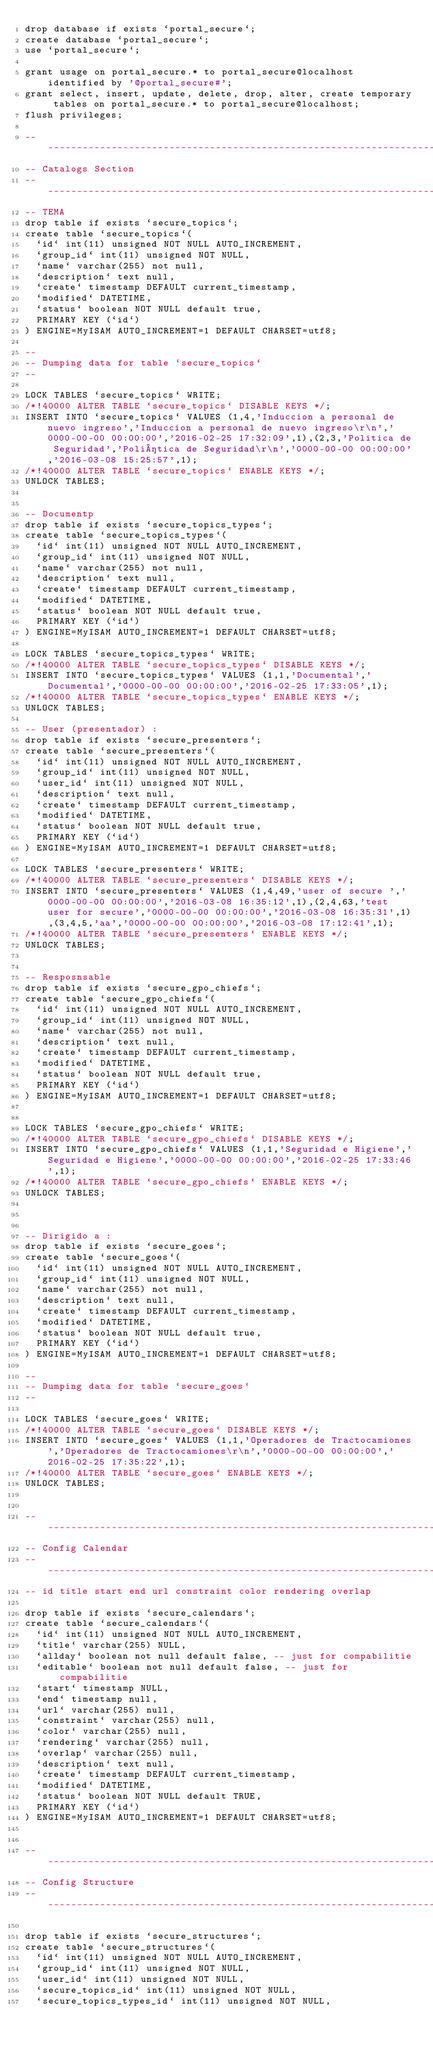<code> <loc_0><loc_0><loc_500><loc_500><_SQL_>drop database if exists `portal_secure`; 
create database `portal_secure`;
use `portal_secure`;

grant usage on portal_secure.* to portal_secure@localhost identified by '@portal_secure#';
grant select, insert, update, delete, drop, alter, create temporary tables on portal_secure.* to portal_secure@localhost;
flush privileges;

-- ---------------------------------------------------------------------------------------------------------------------------------------------------
-- Catalogs Section
-- ---------------------------------------------------------------------------------------------------------------------------------------------------
-- TEMA
drop table if exists `secure_topics`;
create table `secure_topics`(
  `id` int(11) unsigned NOT NULL AUTO_INCREMENT,
  `group_id` int(11) unsigned NOT NULL,
  `name` varchar(255) not null,
  `description` text null,
  `create` timestamp DEFAULT current_timestamp,
  `modified` DATETIME,
  `status` boolean NOT NULL default true,
  PRIMARY KEY (`id`)
) ENGINE=MyISAM AUTO_INCREMENT=1 DEFAULT CHARSET=utf8;

--
-- Dumping data for table `secure_topics`
--

LOCK TABLES `secure_topics` WRITE;
/*!40000 ALTER TABLE `secure_topics` DISABLE KEYS */;
INSERT INTO `secure_topics` VALUES (1,4,'Induccion a personal de nuevo ingreso','Induccion a personal de nuevo ingreso\r\n','0000-00-00 00:00:00','2016-02-25 17:32:09',1),(2,3,'Politica de Seguridad','Poli­tica de Seguridad\r\n','0000-00-00 00:00:00','2016-03-08 15:25:57',1);
/*!40000 ALTER TABLE `secure_topics` ENABLE KEYS */;
UNLOCK TABLES;


-- Documentp
drop table if exists `secure_topics_types`;
create table `secure_topics_types`(
  `id` int(11) unsigned NOT NULL AUTO_INCREMENT,
  `group_id` int(11) unsigned NOT NULL,
  `name` varchar(255) not null,
  `description` text null,
  `create` timestamp DEFAULT current_timestamp,
  `modified` DATETIME,
  `status` boolean NOT NULL default true,
  PRIMARY KEY (`id`)
) ENGINE=MyISAM AUTO_INCREMENT=1 DEFAULT CHARSET=utf8;

LOCK TABLES `secure_topics_types` WRITE;
/*!40000 ALTER TABLE `secure_topics_types` DISABLE KEYS */;
INSERT INTO `secure_topics_types` VALUES (1,1,'Documental','Documental','0000-00-00 00:00:00','2016-02-25 17:33:05',1);
/*!40000 ALTER TABLE `secure_topics_types` ENABLE KEYS */;
UNLOCK TABLES;

-- User (presentador) :
drop table if exists `secure_presenters`;
create table `secure_presenters`(
  `id` int(11) unsigned NOT NULL AUTO_INCREMENT,
  `group_id` int(11) unsigned NOT NULL,
  `user_id` int(11) unsigned NOT NULL,
  `description` text null,
  `create` timestamp DEFAULT current_timestamp,
  `modified` DATETIME,
  `status` boolean NOT NULL default true,
  PRIMARY KEY (`id`)
) ENGINE=MyISAM AUTO_INCREMENT=1 DEFAULT CHARSET=utf8;

LOCK TABLES `secure_presenters` WRITE;
/*!40000 ALTER TABLE `secure_presenters` DISABLE KEYS */;
INSERT INTO `secure_presenters` VALUES (1,4,49,'user of secure ','0000-00-00 00:00:00','2016-03-08 16:35:12',1),(2,4,63,'test user for secure','0000-00-00 00:00:00','2016-03-08 16:35:31',1),(3,4,5,'aa','0000-00-00 00:00:00','2016-03-08 17:12:41',1);
/*!40000 ALTER TABLE `secure_presenters` ENABLE KEYS */;
UNLOCK TABLES;


-- Resposnsable
drop table if exists `secure_gpo_chiefs`;
create table `secure_gpo_chiefs`(
  `id` int(11) unsigned NOT NULL AUTO_INCREMENT,
  `group_id` int(11) unsigned NOT NULL,
  `name` varchar(255) not null,
  `description` text null,
  `create` timestamp DEFAULT current_timestamp,
  `modified` DATETIME,
  `status` boolean NOT NULL default true,
  PRIMARY KEY (`id`)
) ENGINE=MyISAM AUTO_INCREMENT=1 DEFAULT CHARSET=utf8;


LOCK TABLES `secure_gpo_chiefs` WRITE;
/*!40000 ALTER TABLE `secure_gpo_chiefs` DISABLE KEYS */;
INSERT INTO `secure_gpo_chiefs` VALUES (1,1,'Seguridad e Higiene','Seguridad e Higiene','0000-00-00 00:00:00','2016-02-25 17:33:46',1);
/*!40000 ALTER TABLE `secure_gpo_chiefs` ENABLE KEYS */;
UNLOCK TABLES;



-- Dirigido a :
drop table if exists `secure_goes`;
create table `secure_goes`(
  `id` int(11) unsigned NOT NULL AUTO_INCREMENT,
  `group_id` int(11) unsigned NOT NULL,
  `name` varchar(255) not null,
  `description` text null,
  `create` timestamp DEFAULT current_timestamp,
  `modified` DATETIME,
  `status` boolean NOT NULL default true,
  PRIMARY KEY (`id`)
) ENGINE=MyISAM AUTO_INCREMENT=1 DEFAULT CHARSET=utf8;

--
-- Dumping data for table `secure_goes`
--

LOCK TABLES `secure_goes` WRITE;
/*!40000 ALTER TABLE `secure_goes` DISABLE KEYS */;
INSERT INTO `secure_goes` VALUES (1,1,'Operadores de Tractocamiones','Operadores de Tractocamiones\r\n','0000-00-00 00:00:00','2016-02-25 17:35:22',1);
/*!40000 ALTER TABLE `secure_goes` ENABLE KEYS */;
UNLOCK TABLES;


-- ---------------------------------------------------------------------------------------------------------------------------------------------------
-- Config Calendar
-- ---------------------------------------------------------------------------------------------------------------------------------------------------
-- id title start end url constraint color rendering overlap

drop table if exists `secure_calendars`;
create table `secure_calendars`(
  `id` int(11) unsigned NOT NULL AUTO_INCREMENT,
  `title` varchar(255) NULL,
  `allday` boolean not null default false, -- just for compabilitie
  `editable` boolean not null default false, -- just for compabilitie
  `start` timestamp NULL,
  `end` timestamp null,
  `url` varchar(255) null,
  `constraint` varchar(255) null,
  `color` varchar(255) null,
  `rendering` varchar(255) null,
  `overlap` varchar(255) null,
  `description` text null,
  `create` timestamp DEFAULT current_timestamp,
  `modified` DATETIME,
  `status` boolean NOT NULL default TRUE,
  PRIMARY KEY (`id`)
) ENGINE=MyISAM AUTO_INCREMENT=1 DEFAULT CHARSET=utf8;


-- ---------------------------------------------------------------------------------------------------------------------------------------------------
-- Config Structure
-- ---------------------------------------------------------------------------------------------------------------------------------------------------

drop table if exists `secure_structures`;
create table `secure_structures`(
  `id` int(11) unsigned NOT NULL AUTO_INCREMENT,
  `group_id` int(11) unsigned NOT NULL,
  `user_id` int(11) unsigned NOT NULL,
  `secure_topics_id` int(11) unsigned NOT NULL,
  `secure_topics_types_id` int(11) unsigned NOT NULL,</code> 